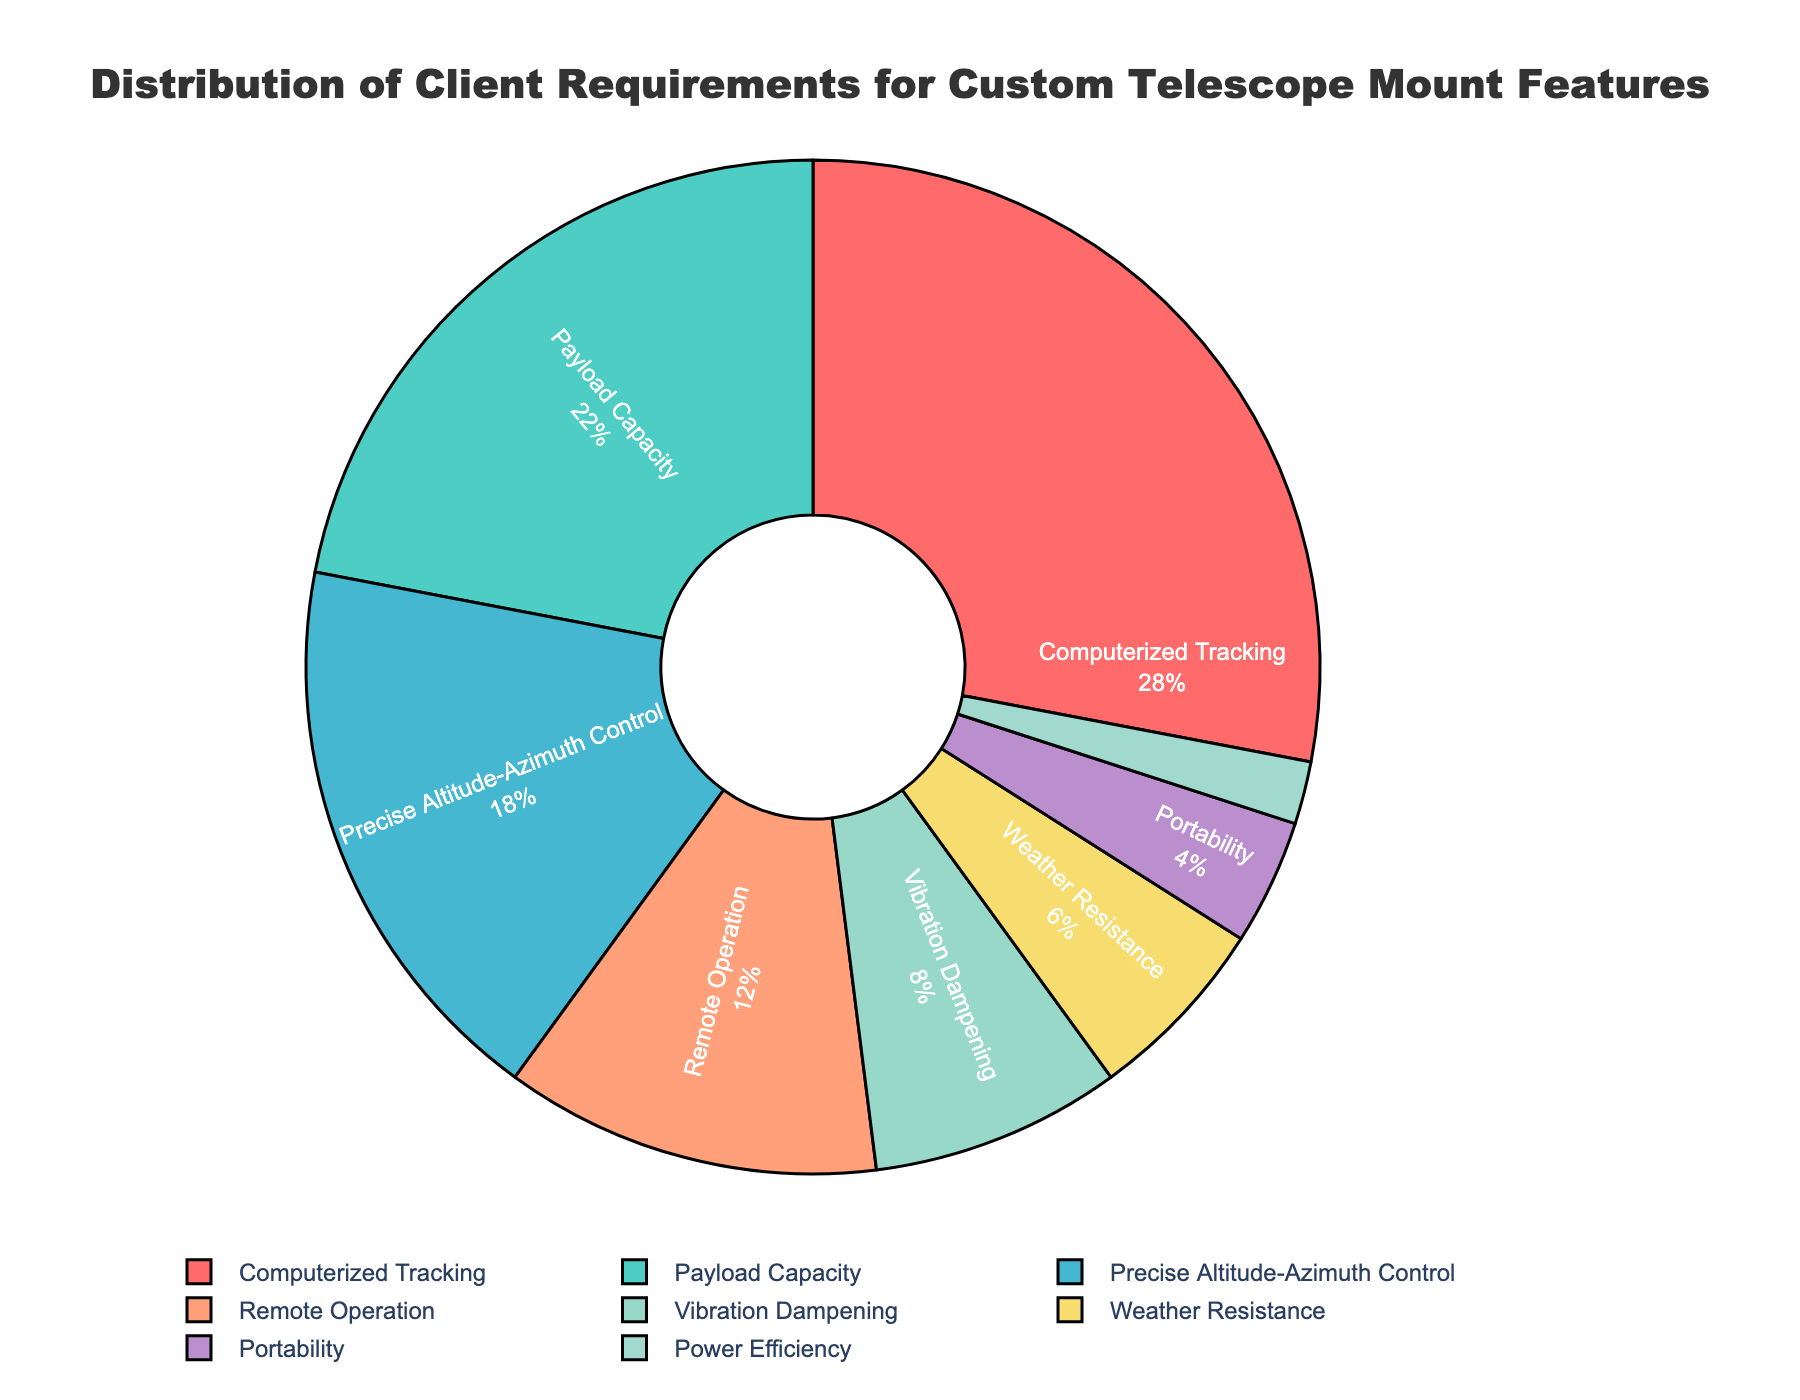Which feature has the highest percentage of client requirements? The feature with the largest portion of the pie chart represents the highest percentage. According to the figure, "Computerized Tracking" is the largest segment.
Answer: Computerized Tracking Which two features combined account for half of the client requirements? To find this, look for two features whose percentages add up to approximately 50%. "Computerized Tracking" is 28% and "Payload Capacity" is 22%, summing to exactly 50%.
Answer: Computerized Tracking and Payload Capacity What is the difference in percentage between the highest and lowest client requirement features? Identify the percentage of the highest feature ("Computerized Tracking" at 28%) and the lowest feature ("Power Efficiency" at 2%). Subtract the smallest percentage from the largest (28% - 2%).
Answer: 26% How many features have a percentage greater than 10%? Count the segments that have percentages greater than 10%. "Computerized Tracking" (28%), "Payload Capacity" (22%), "Precise Altitude-Azimuth Control" (18%), and "Remote Operation" (12%) all exceed 10%.
Answer: 4 Which feature is represented by the green color in the pie chart? Look at the legend and color coding in the pie chart to identify the feature associated with green. "Payload Capacity" is green in the chart.
Answer: Payload Capacity What percentage of client requirements does Remote Operation and Portability together represent? Add the percentages for "Remote Operation" (12%) and "Portability" (4%). The sum is 12% + 4%.
Answer: 16% Which features are represented by colors in the blue family? Identify the segments on the chart that are shades of blue. "Payload Capacity" and "Power Efficiency" are in blue shades.
Answer: Payload Capacity and Power Efficiency What is the combined percentage for Vibration Dampening, Weather Resistance, and Portability? Sum the percentages of the three specified features: "Vibration Dampening" (8%), "Weather Resistance" (6%), and "Portability" (4%). The total is 8% + 6% + 4%.
Answer: 18% Compare the percentage of Precise Altitude-Azimuth Control to Weather Resistance. Which one has a higher percentage and by how much? Determine the percentages of both features. "Precise Altitude-Azimuth Control" is 18% and "Weather Resistance" is 6%. Subtract the smaller from the larger (18% - 6%).
Answer: Precise Altitude-Azimuth Control by 12% What is the percentage difference between Payload Capacity and Vibration Dampening? Identify their percentages: "Payload Capacity" is 22% and "Vibration Dampening" is 8%. Subtract the smaller percentage from the larger (22% - 8%).
Answer: 14% 